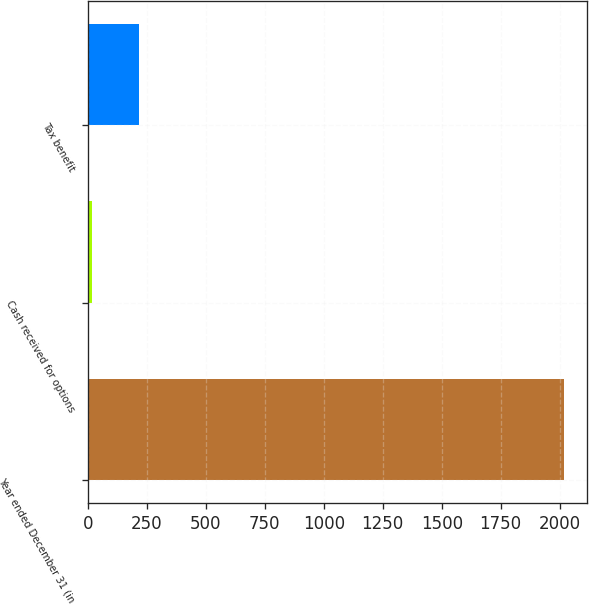<chart> <loc_0><loc_0><loc_500><loc_500><bar_chart><fcel>Year ended December 31 (in<fcel>Cash received for options<fcel>Tax benefit<nl><fcel>2017<fcel>18<fcel>217.9<nl></chart> 